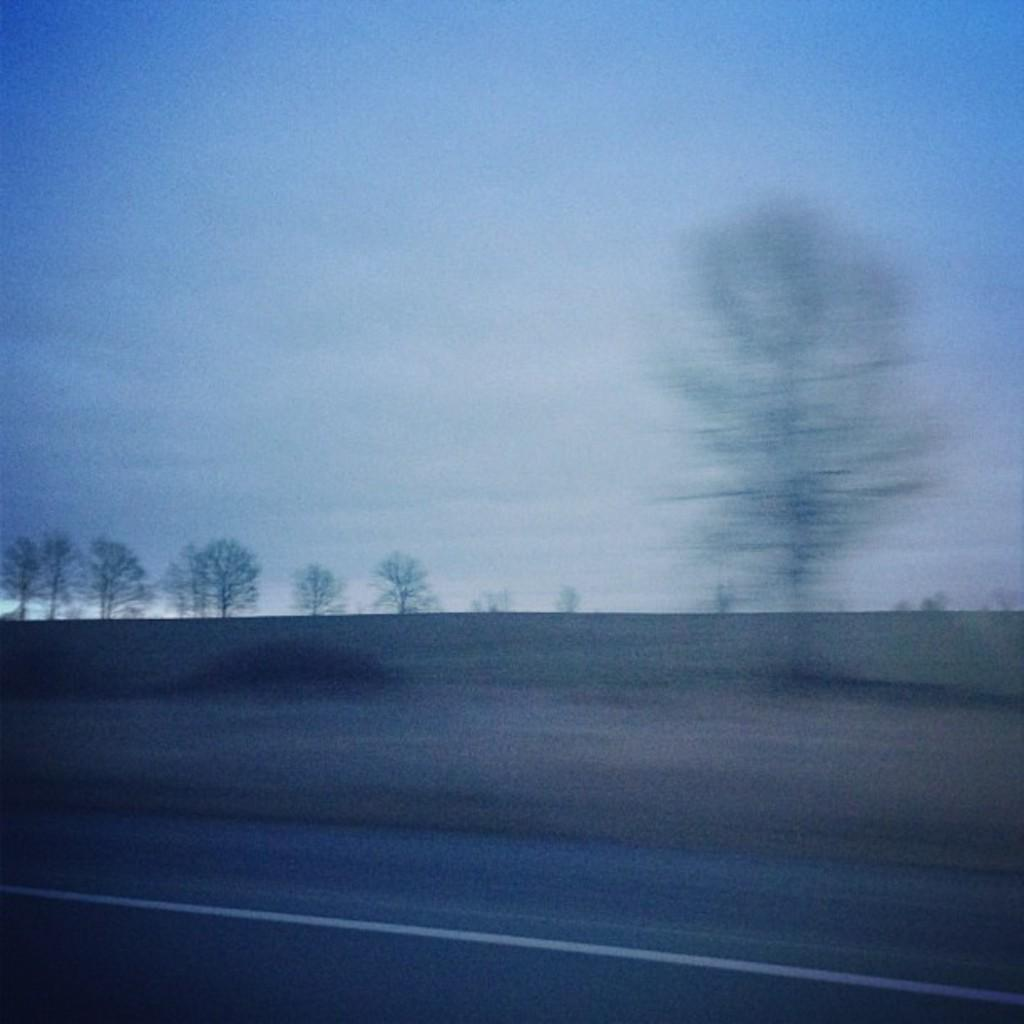What is located in front of the image? There is a road in front of the image. What can be seen in the background of the image? There are trees and the sky visible in the background of the image. Can you see the family enjoying cakes in the image? There is no family or cakes present in the image. What type of rhythm can be heard in the image? There is no sound or rhythm present in the image, as it is a still image. 